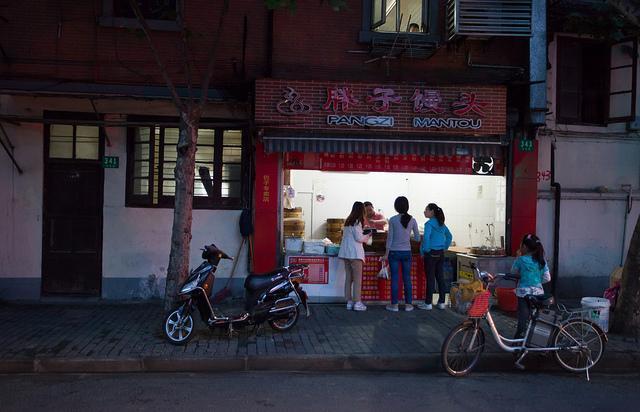How many people are here?
Give a very brief answer. 5. How many bikes?
Give a very brief answer. 2. How many wheels?
Give a very brief answer. 4. How many people can be seen?
Give a very brief answer. 4. How many elephant is there?
Give a very brief answer. 0. 